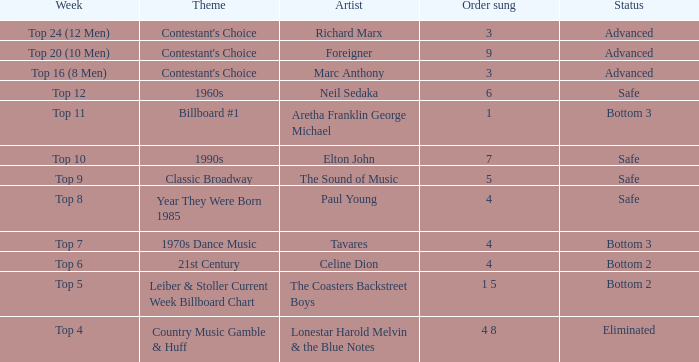What week did the contestant finish in the bottom 2 with a Celine Dion song? Top 6. 